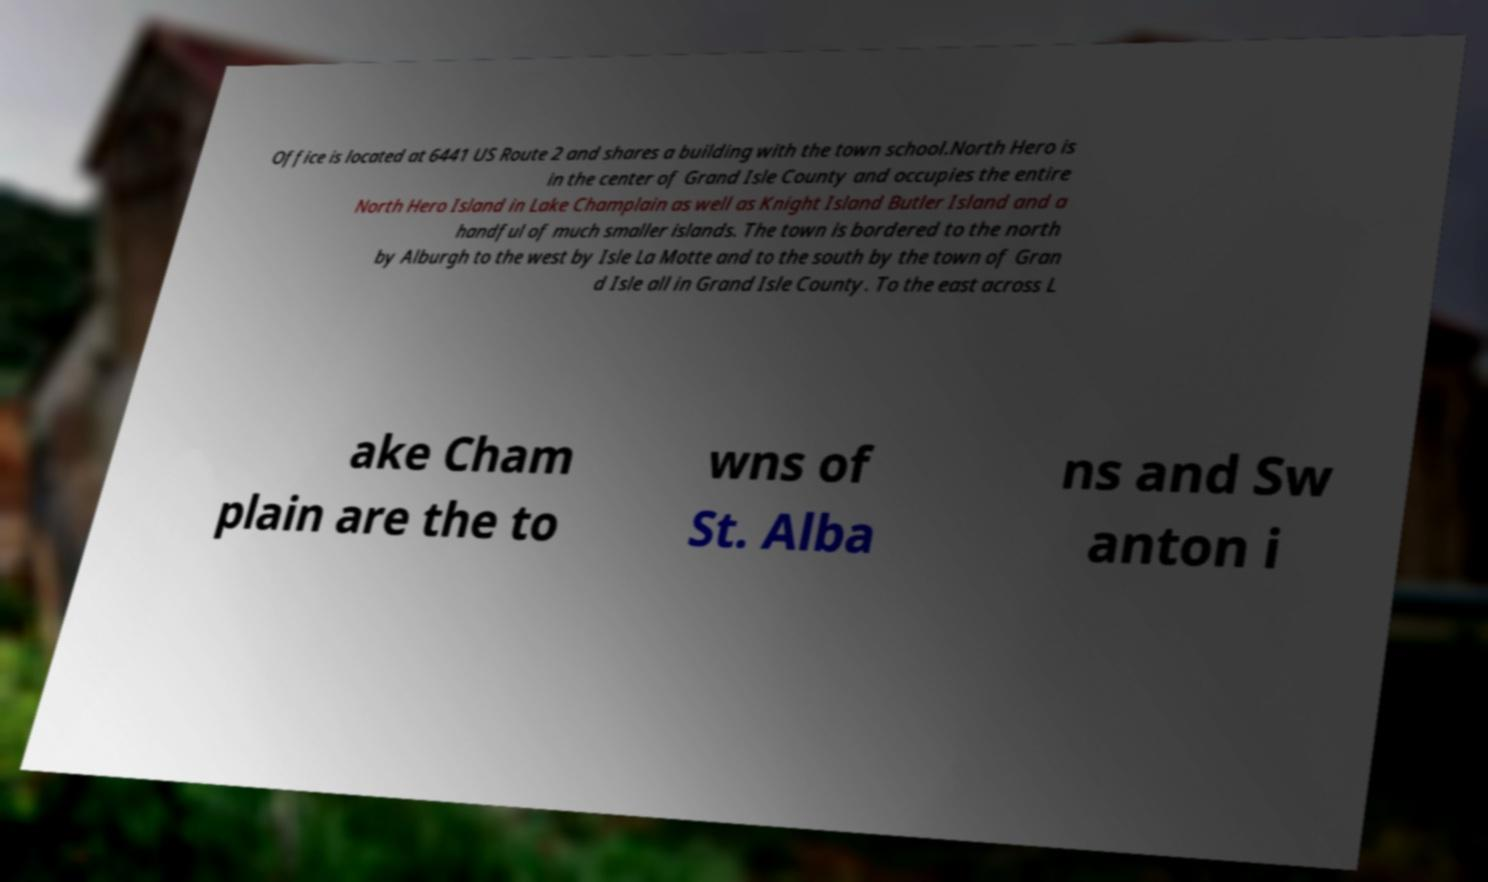Please read and relay the text visible in this image. What does it say? Office is located at 6441 US Route 2 and shares a building with the town school.North Hero is in the center of Grand Isle County and occupies the entire North Hero Island in Lake Champlain as well as Knight Island Butler Island and a handful of much smaller islands. The town is bordered to the north by Alburgh to the west by Isle La Motte and to the south by the town of Gran d Isle all in Grand Isle County. To the east across L ake Cham plain are the to wns of St. Alba ns and Sw anton i 